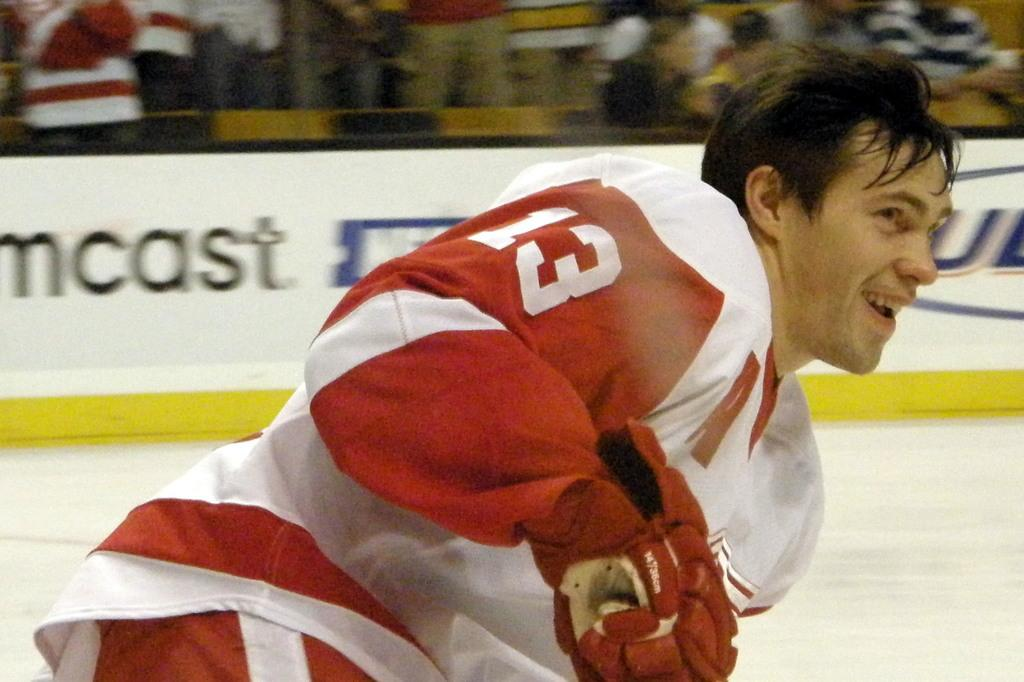What is the main subject of the image? There is a player in the image. What is the player's expression? The player is smiling. What can be seen behind the player? There is a banner behind the player. How would you describe the appearance of the banner's background? The background of the banner is blurry. What type of waste is being discussed by the committee in the image? There is no committee or waste present in the image; it features a player and a banner. 